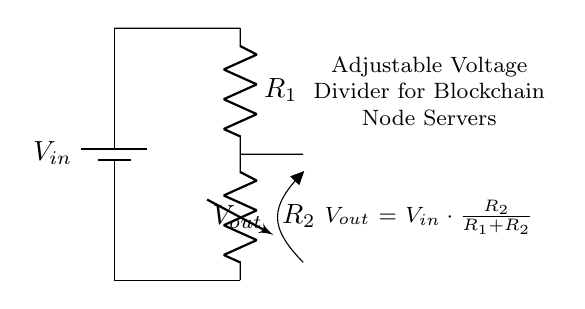What is the input voltage in this circuit? The input voltage is labeled as V_in and is supplied by the battery.
Answer: V_in What type of resistor is R2 in this circuit? R2 is a variable resistor, which allows for adjustment of resistance and, consequently, fine-tuning of the output voltage.
Answer: Variable resistor What is the relationship of output voltage to the input voltage? The output voltage is determined by the formula V_out = V_in * (R2 / (R1 + R2)), indicating that it is a fraction of the input voltage based on the resistance values.
Answer: A fraction What happens to V_out if R1 is increased while keeping R2 constant? Increasing R1 while keeping R2 constant decreases the output voltage because the fraction R2 / (R1 + R2) becomes smaller.
Answer: Decreases How can this voltage divider be used to fine-tune voltage levels? This voltage divider can provide adjustable output voltage by varying R2, which allows for precise control over voltage levels needed by blockchain node servers.
Answer: By varying R2 What is the output voltage formula in this circuit? The formula given in the circuit diagram specifies how to calculate V_out based on V_in and resistance values, V_out = V_in * (R2 / (R1 + R2)).
Answer: V_out = V_in * (R2 / (R1 + R2)) 